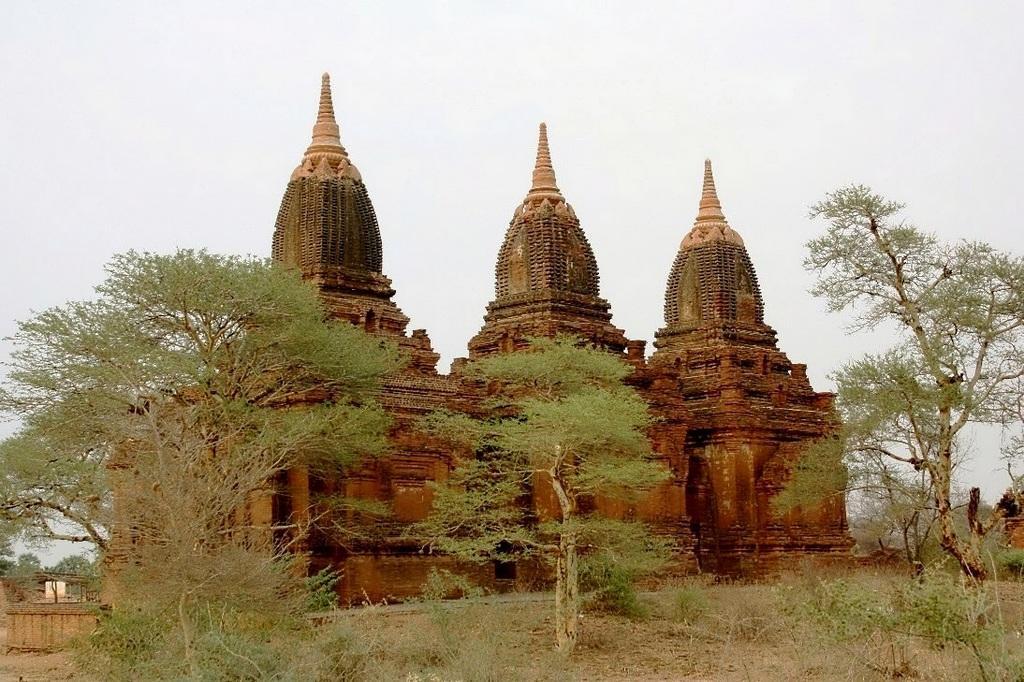Describe this image in one or two sentences. In the picture there are three temples present, there are trees, there is a clear sky. 